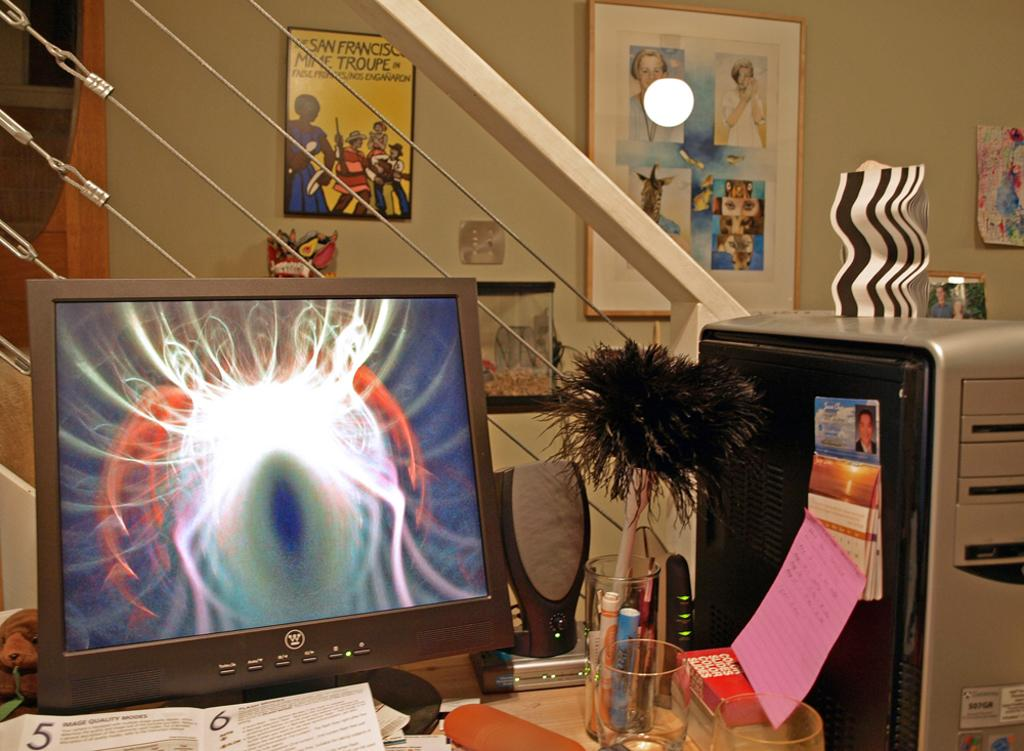<image>
Summarize the visual content of the image. a computer desk with an eyeball screensaver and a 'w' logo on the rim of the computer 